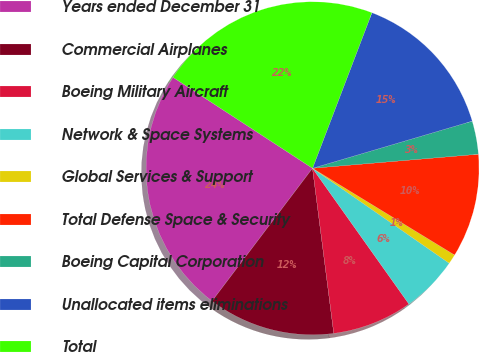Convert chart to OTSL. <chart><loc_0><loc_0><loc_500><loc_500><pie_chart><fcel>Years ended December 31<fcel>Commercial Airplanes<fcel>Boeing Military Aircraft<fcel>Network & Space Systems<fcel>Global Services & Support<fcel>Total Defense Space & Security<fcel>Boeing Capital Corporation<fcel>Unallocated items eliminations<fcel>Total<nl><fcel>23.89%<fcel>12.35%<fcel>7.79%<fcel>5.51%<fcel>0.94%<fcel>10.07%<fcel>3.22%<fcel>14.63%<fcel>21.61%<nl></chart> 